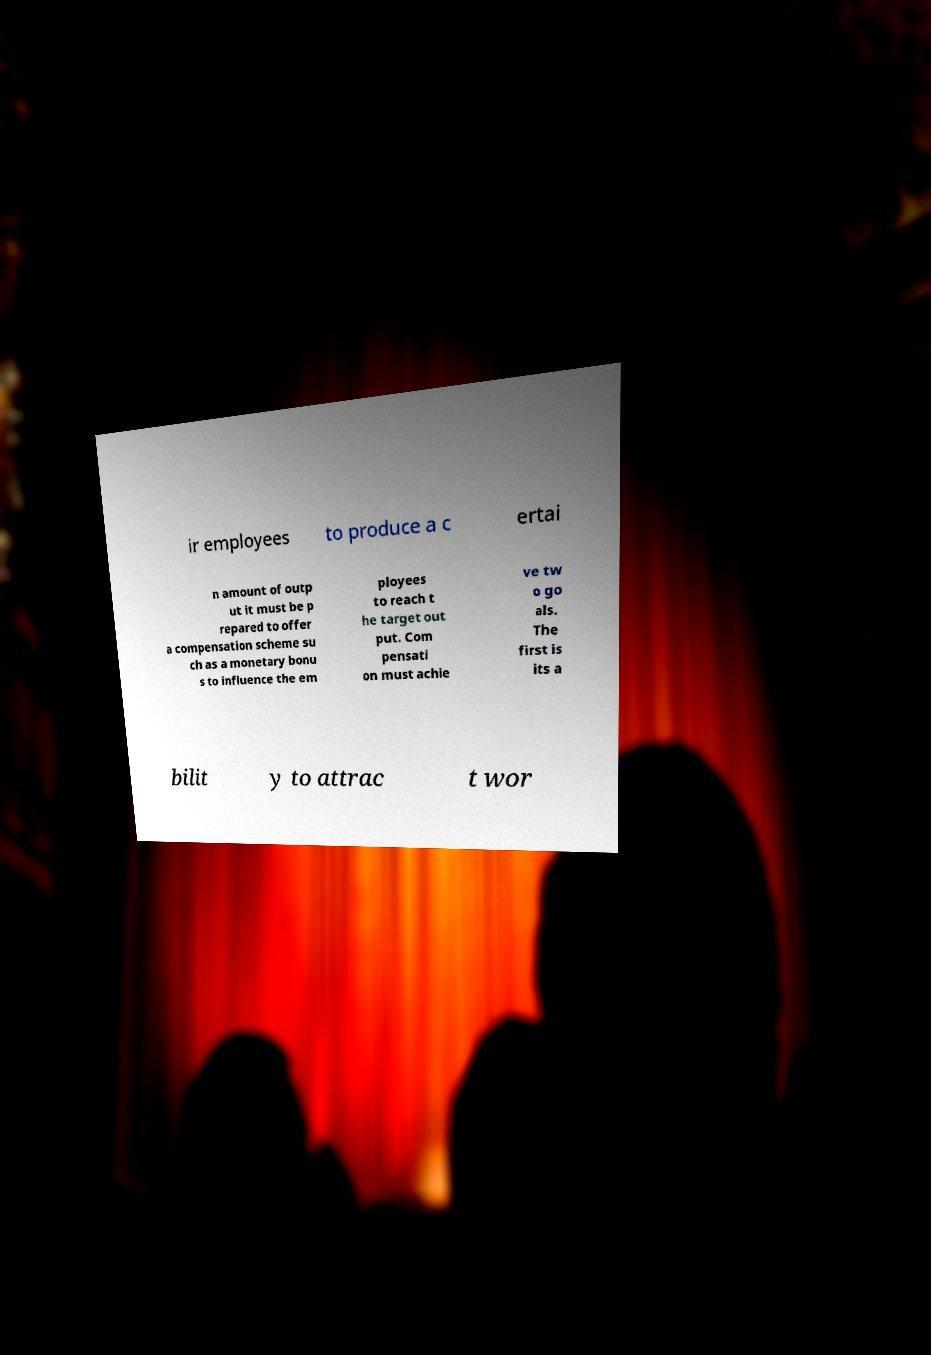Can you read and provide the text displayed in the image?This photo seems to have some interesting text. Can you extract and type it out for me? ir employees to produce a c ertai n amount of outp ut it must be p repared to offer a compensation scheme su ch as a monetary bonu s to influence the em ployees to reach t he target out put. Com pensati on must achie ve tw o go als. The first is its a bilit y to attrac t wor 